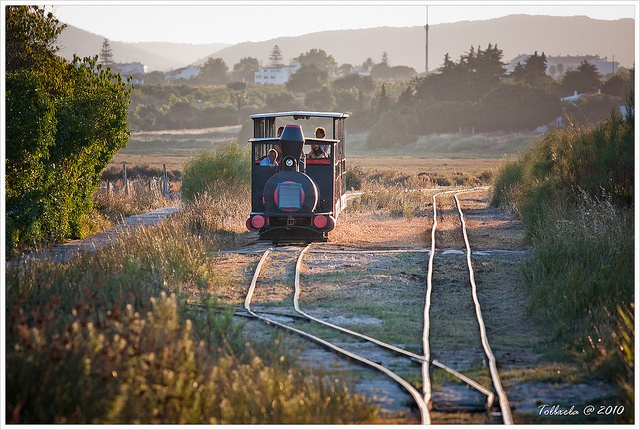Describe the objects in this image and their specific colors. I can see train in lightgray, black, darkgray, and gray tones, people in lightgray, black, brown, maroon, and darkgray tones, people in lightgray, maroon, blue, black, and gray tones, and people in lightgray, black, brown, and maroon tones in this image. 